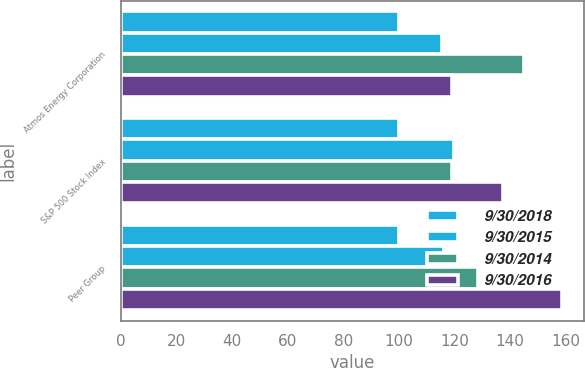Convert chart to OTSL. <chart><loc_0><loc_0><loc_500><loc_500><stacked_bar_chart><ecel><fcel>Atmos Energy Corporation<fcel>S&P 500 Stock Index<fcel>Peer Group<nl><fcel>9/30/2018<fcel>100<fcel>100<fcel>100<nl><fcel>9/30/2015<fcel>115.52<fcel>119.73<fcel>116.03<nl><fcel>9/30/2014<fcel>145.03<fcel>119<fcel>128.49<nl><fcel>9/30/2016<fcel>119<fcel>137.36<fcel>158.62<nl></chart> 